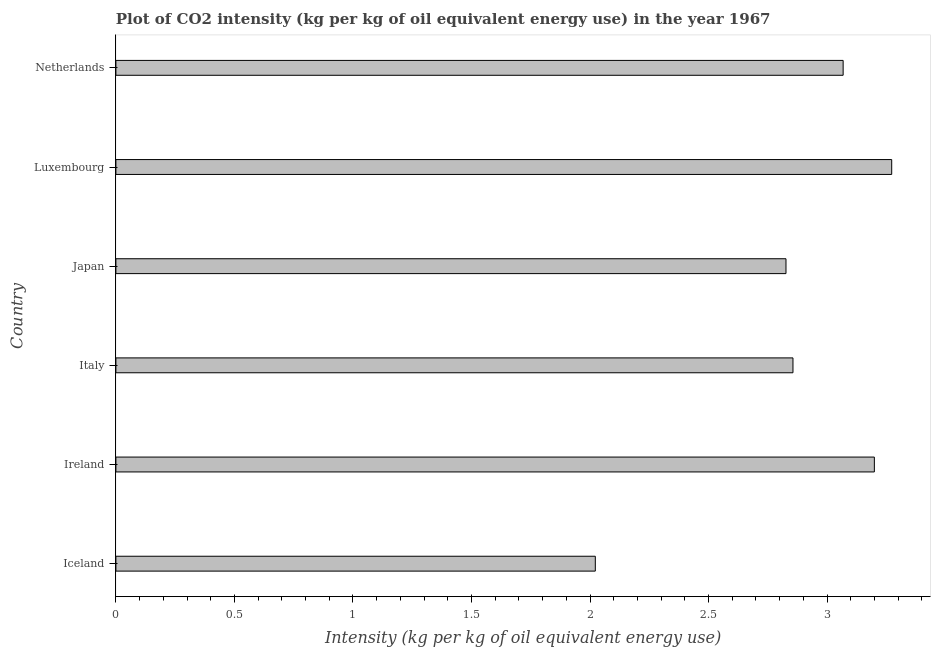Does the graph contain grids?
Your answer should be very brief. No. What is the title of the graph?
Keep it short and to the point. Plot of CO2 intensity (kg per kg of oil equivalent energy use) in the year 1967. What is the label or title of the X-axis?
Provide a short and direct response. Intensity (kg per kg of oil equivalent energy use). What is the co2 intensity in Netherlands?
Provide a short and direct response. 3.07. Across all countries, what is the maximum co2 intensity?
Offer a terse response. 3.27. Across all countries, what is the minimum co2 intensity?
Provide a succinct answer. 2.02. In which country was the co2 intensity maximum?
Provide a succinct answer. Luxembourg. In which country was the co2 intensity minimum?
Give a very brief answer. Iceland. What is the sum of the co2 intensity?
Give a very brief answer. 17.25. What is the difference between the co2 intensity in Italy and Netherlands?
Keep it short and to the point. -0.21. What is the average co2 intensity per country?
Keep it short and to the point. 2.87. What is the median co2 intensity?
Give a very brief answer. 2.96. What is the ratio of the co2 intensity in Luxembourg to that in Netherlands?
Offer a very short reply. 1.07. Is the difference between the co2 intensity in Iceland and Netherlands greater than the difference between any two countries?
Make the answer very short. No. What is the difference between the highest and the second highest co2 intensity?
Offer a very short reply. 0.07. What is the difference between the highest and the lowest co2 intensity?
Provide a succinct answer. 1.25. In how many countries, is the co2 intensity greater than the average co2 intensity taken over all countries?
Offer a terse response. 3. How many bars are there?
Provide a short and direct response. 6. How many countries are there in the graph?
Give a very brief answer. 6. Are the values on the major ticks of X-axis written in scientific E-notation?
Ensure brevity in your answer.  No. What is the Intensity (kg per kg of oil equivalent energy use) in Iceland?
Keep it short and to the point. 2.02. What is the Intensity (kg per kg of oil equivalent energy use) in Ireland?
Make the answer very short. 3.2. What is the Intensity (kg per kg of oil equivalent energy use) of Italy?
Your answer should be compact. 2.86. What is the Intensity (kg per kg of oil equivalent energy use) of Japan?
Offer a very short reply. 2.83. What is the Intensity (kg per kg of oil equivalent energy use) in Luxembourg?
Provide a short and direct response. 3.27. What is the Intensity (kg per kg of oil equivalent energy use) of Netherlands?
Offer a very short reply. 3.07. What is the difference between the Intensity (kg per kg of oil equivalent energy use) in Iceland and Ireland?
Offer a terse response. -1.18. What is the difference between the Intensity (kg per kg of oil equivalent energy use) in Iceland and Italy?
Give a very brief answer. -0.83. What is the difference between the Intensity (kg per kg of oil equivalent energy use) in Iceland and Japan?
Provide a succinct answer. -0.8. What is the difference between the Intensity (kg per kg of oil equivalent energy use) in Iceland and Luxembourg?
Offer a very short reply. -1.25. What is the difference between the Intensity (kg per kg of oil equivalent energy use) in Iceland and Netherlands?
Keep it short and to the point. -1.05. What is the difference between the Intensity (kg per kg of oil equivalent energy use) in Ireland and Italy?
Your answer should be compact. 0.34. What is the difference between the Intensity (kg per kg of oil equivalent energy use) in Ireland and Japan?
Your response must be concise. 0.37. What is the difference between the Intensity (kg per kg of oil equivalent energy use) in Ireland and Luxembourg?
Ensure brevity in your answer.  -0.07. What is the difference between the Intensity (kg per kg of oil equivalent energy use) in Ireland and Netherlands?
Keep it short and to the point. 0.13. What is the difference between the Intensity (kg per kg of oil equivalent energy use) in Italy and Japan?
Provide a succinct answer. 0.03. What is the difference between the Intensity (kg per kg of oil equivalent energy use) in Italy and Luxembourg?
Offer a terse response. -0.42. What is the difference between the Intensity (kg per kg of oil equivalent energy use) in Italy and Netherlands?
Provide a succinct answer. -0.21. What is the difference between the Intensity (kg per kg of oil equivalent energy use) in Japan and Luxembourg?
Offer a very short reply. -0.45. What is the difference between the Intensity (kg per kg of oil equivalent energy use) in Japan and Netherlands?
Keep it short and to the point. -0.24. What is the difference between the Intensity (kg per kg of oil equivalent energy use) in Luxembourg and Netherlands?
Your response must be concise. 0.2. What is the ratio of the Intensity (kg per kg of oil equivalent energy use) in Iceland to that in Ireland?
Give a very brief answer. 0.63. What is the ratio of the Intensity (kg per kg of oil equivalent energy use) in Iceland to that in Italy?
Offer a terse response. 0.71. What is the ratio of the Intensity (kg per kg of oil equivalent energy use) in Iceland to that in Japan?
Provide a succinct answer. 0.71. What is the ratio of the Intensity (kg per kg of oil equivalent energy use) in Iceland to that in Luxembourg?
Give a very brief answer. 0.62. What is the ratio of the Intensity (kg per kg of oil equivalent energy use) in Iceland to that in Netherlands?
Offer a very short reply. 0.66. What is the ratio of the Intensity (kg per kg of oil equivalent energy use) in Ireland to that in Italy?
Provide a succinct answer. 1.12. What is the ratio of the Intensity (kg per kg of oil equivalent energy use) in Ireland to that in Japan?
Offer a terse response. 1.13. What is the ratio of the Intensity (kg per kg of oil equivalent energy use) in Ireland to that in Netherlands?
Keep it short and to the point. 1.04. What is the ratio of the Intensity (kg per kg of oil equivalent energy use) in Italy to that in Luxembourg?
Your answer should be compact. 0.87. What is the ratio of the Intensity (kg per kg of oil equivalent energy use) in Japan to that in Luxembourg?
Keep it short and to the point. 0.86. What is the ratio of the Intensity (kg per kg of oil equivalent energy use) in Japan to that in Netherlands?
Provide a succinct answer. 0.92. What is the ratio of the Intensity (kg per kg of oil equivalent energy use) in Luxembourg to that in Netherlands?
Ensure brevity in your answer.  1.07. 